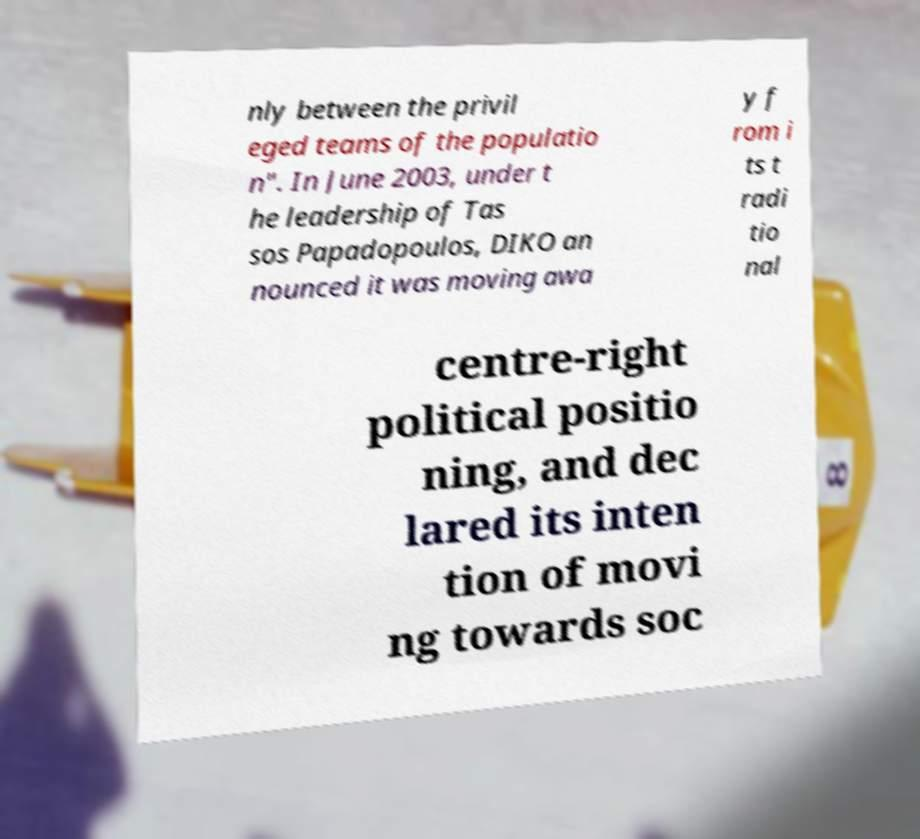Can you accurately transcribe the text from the provided image for me? nly between the privil eged teams of the populatio n". In June 2003, under t he leadership of Tas sos Papadopoulos, DIKO an nounced it was moving awa y f rom i ts t radi tio nal centre-right political positio ning, and dec lared its inten tion of movi ng towards soc 